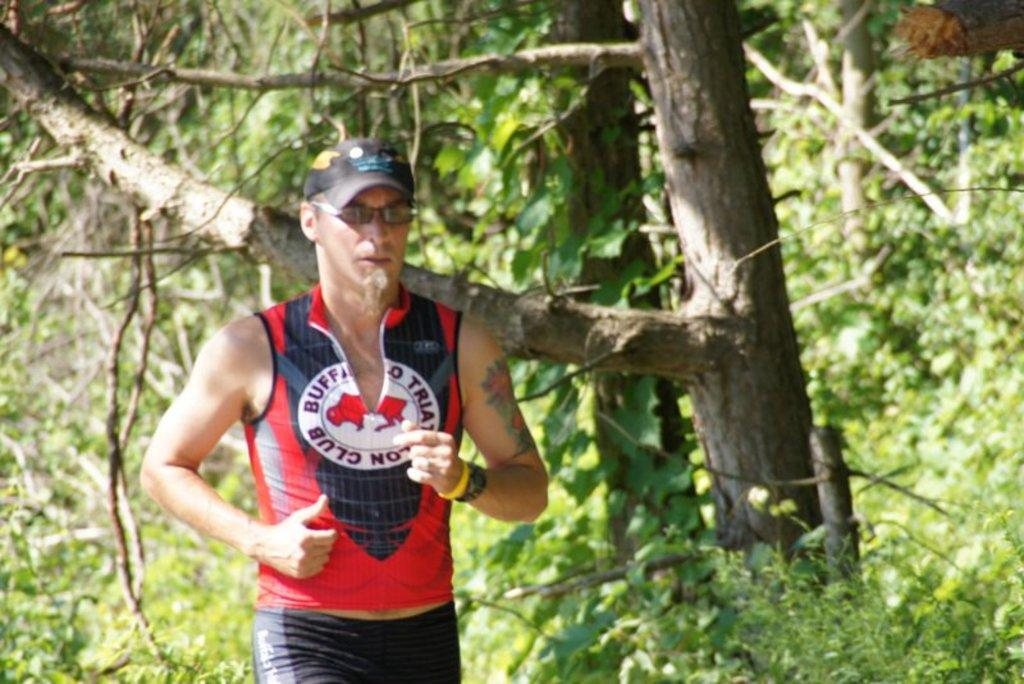Provide a one-sentence caption for the provided image. A running man is wearing a Buffalo Triathlon Club shirt. 